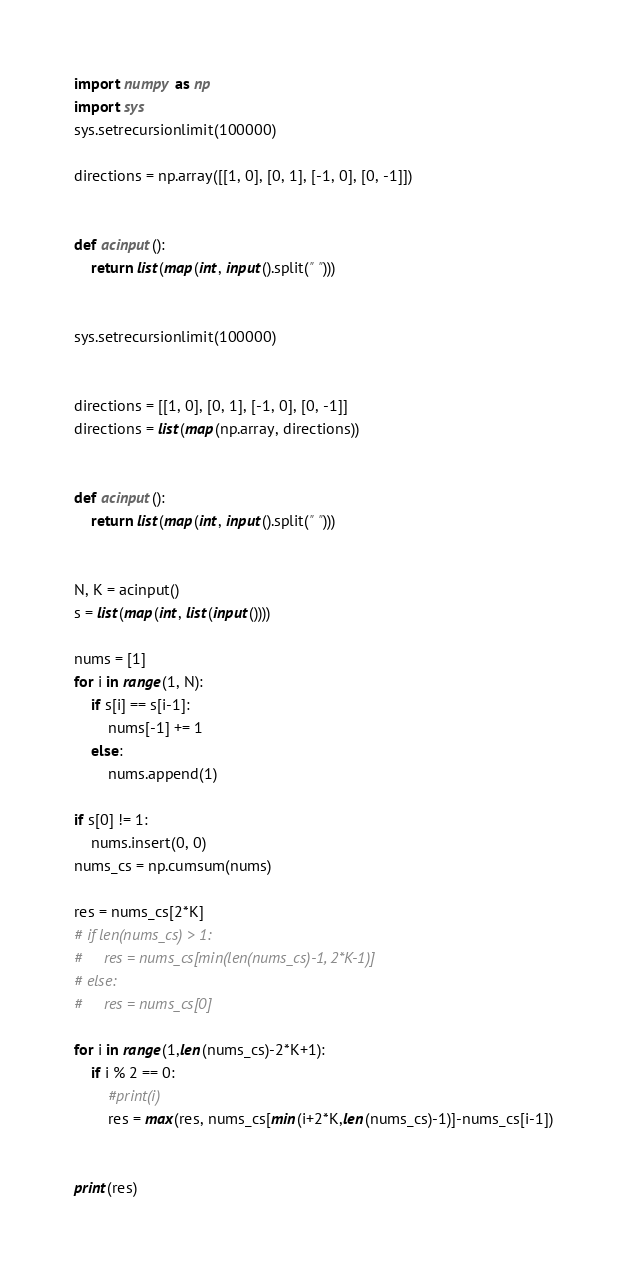<code> <loc_0><loc_0><loc_500><loc_500><_Python_>
import numpy as np
import sys
sys.setrecursionlimit(100000)

directions = np.array([[1, 0], [0, 1], [-1, 0], [0, -1]])


def acinput():
    return list(map(int, input().split(" ")))


sys.setrecursionlimit(100000)


directions = [[1, 0], [0, 1], [-1, 0], [0, -1]]
directions = list(map(np.array, directions))


def acinput():
    return list(map(int, input().split(" ")))


N, K = acinput()
s = list(map(int, list(input())))

nums = [1]
for i in range(1, N):
    if s[i] == s[i-1]:
        nums[-1] += 1
    else:
        nums.append(1)

if s[0] != 1:
    nums.insert(0, 0)
nums_cs = np.cumsum(nums)

res = nums_cs[2*K]
# if len(nums_cs) > 1:
#     res = nums_cs[min(len(nums_cs)-1, 2*K-1)]
# else:
#     res = nums_cs[0]

for i in range(1,len(nums_cs)-2*K+1):
    if i % 2 == 0:
        #print(i)
        res = max(res, nums_cs[min(i+2*K,len(nums_cs)-1)]-nums_cs[i-1])


print(res)</code> 